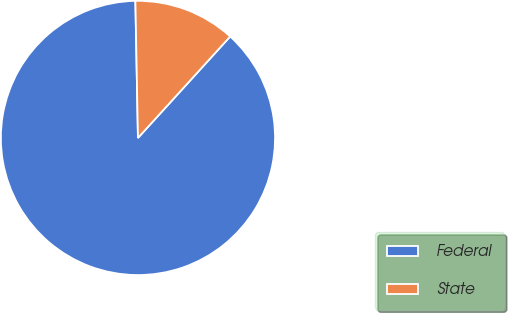Convert chart to OTSL. <chart><loc_0><loc_0><loc_500><loc_500><pie_chart><fcel>Federal<fcel>State<nl><fcel>87.96%<fcel>12.04%<nl></chart> 